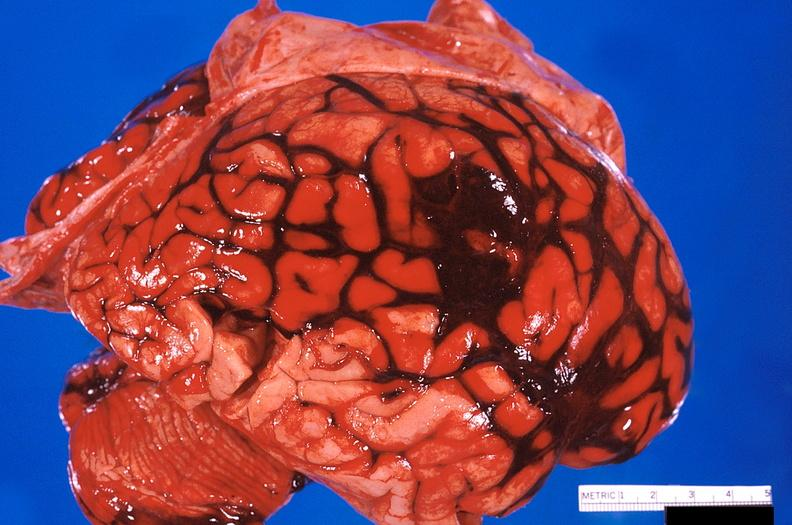s nervous present?
Answer the question using a single word or phrase. Yes 